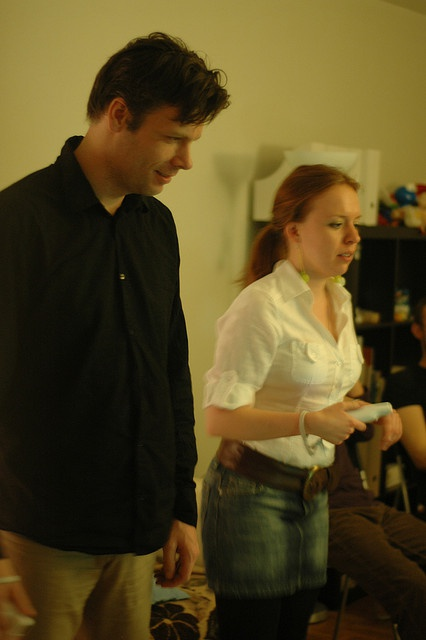Describe the objects in this image and their specific colors. I can see people in olive, black, and maroon tones, people in olive, black, and tan tones, and remote in olive and tan tones in this image. 